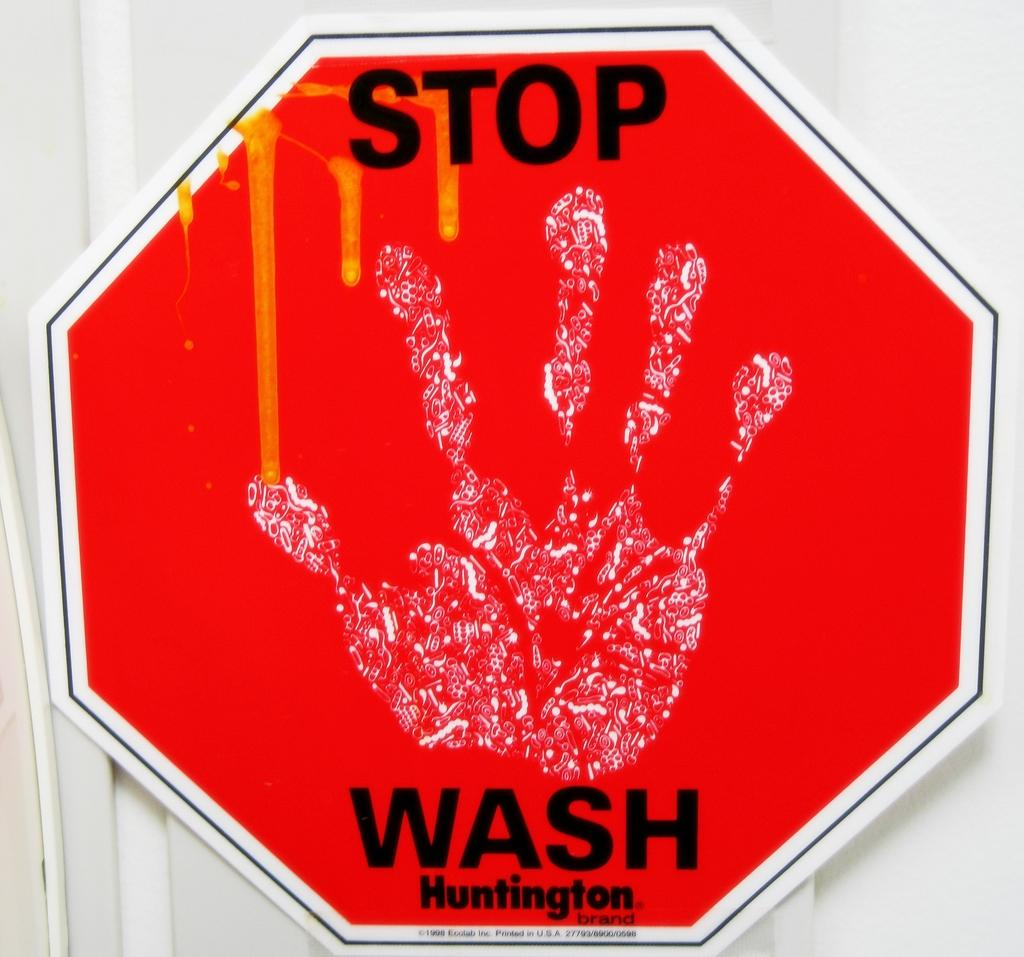<image>
Provide a brief description of the given image. The red stop sign says STOP WASH Huntington 